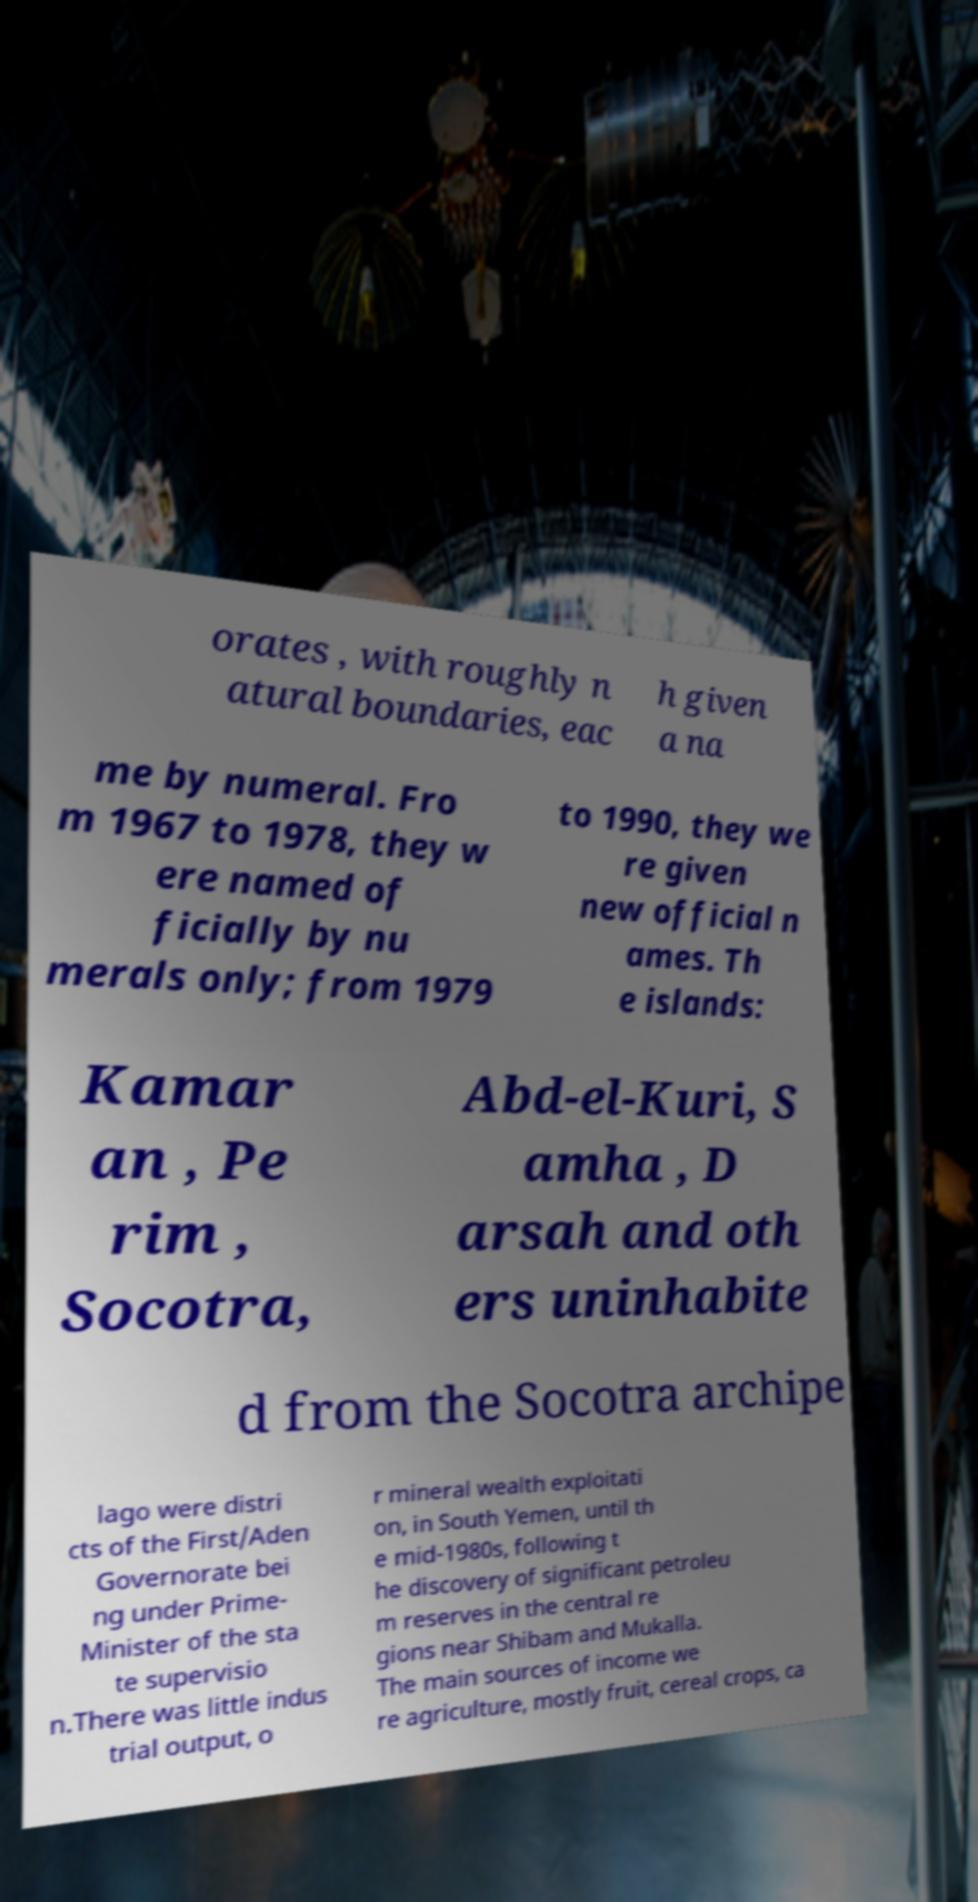Can you accurately transcribe the text from the provided image for me? orates , with roughly n atural boundaries, eac h given a na me by numeral. Fro m 1967 to 1978, they w ere named of ficially by nu merals only; from 1979 to 1990, they we re given new official n ames. Th e islands: Kamar an , Pe rim , Socotra, Abd-el-Kuri, S amha , D arsah and oth ers uninhabite d from the Socotra archipe lago were distri cts of the First/Aden Governorate bei ng under Prime- Minister of the sta te supervisio n.There was little indus trial output, o r mineral wealth exploitati on, in South Yemen, until th e mid-1980s, following t he discovery of significant petroleu m reserves in the central re gions near Shibam and Mukalla. The main sources of income we re agriculture, mostly fruit, cereal crops, ca 